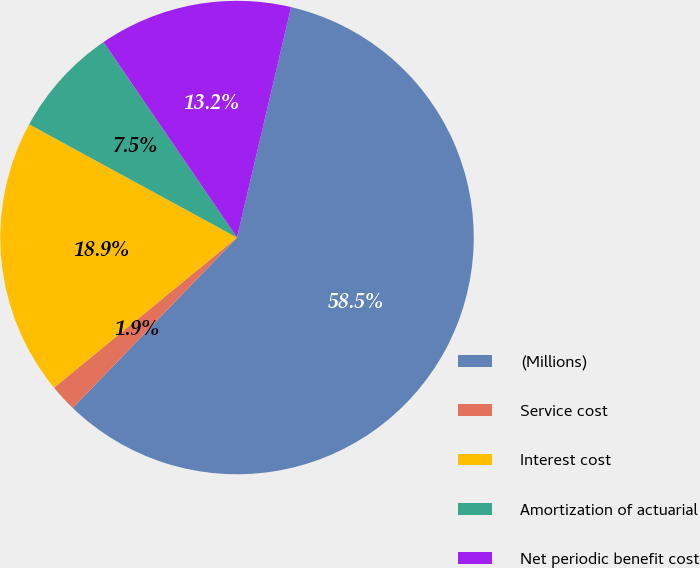<chart> <loc_0><loc_0><loc_500><loc_500><pie_chart><fcel>(Millions)<fcel>Service cost<fcel>Interest cost<fcel>Amortization of actuarial<fcel>Net periodic benefit cost<nl><fcel>58.54%<fcel>1.86%<fcel>18.87%<fcel>7.53%<fcel>13.2%<nl></chart> 